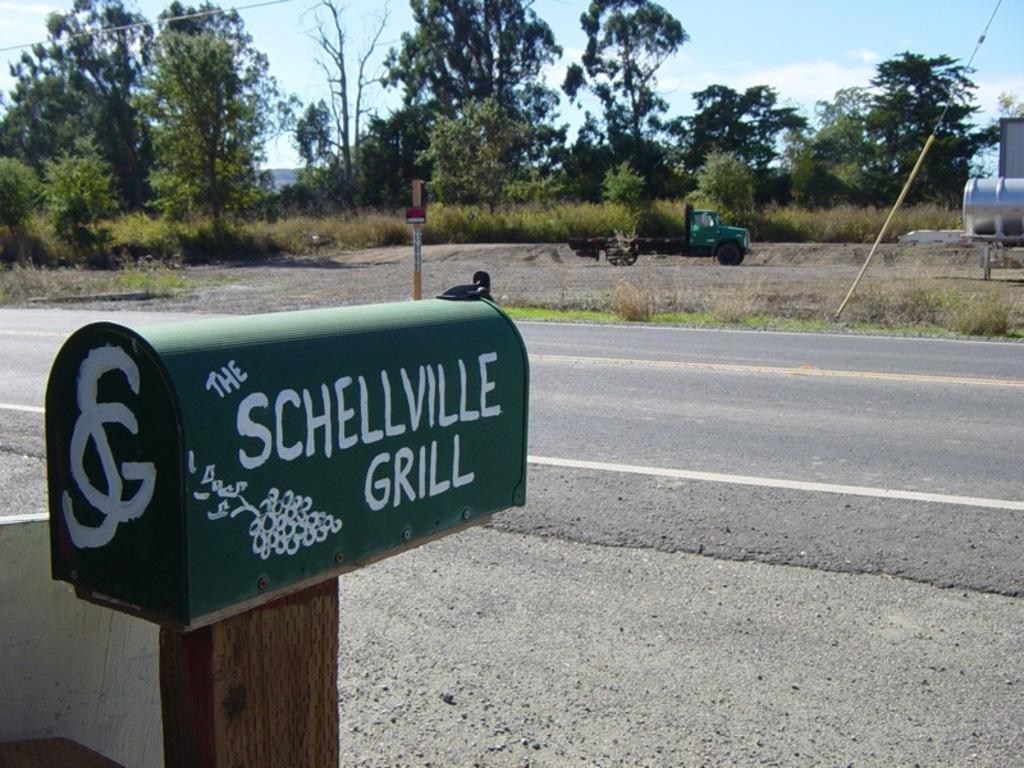Can you describe this image briefly? In this image we can see the road, one object with text and images attached to the wooden pole on the left side of the image. There is one white object on the bottom left side of the image, one vehicle on the ground, some objects on the ground on the right side of the image, two wires, one object with yellow pole near the road, one object on the ground near the road on the left side of the image, some trees, bushes and grass on the ground. At the top there is the sky. 